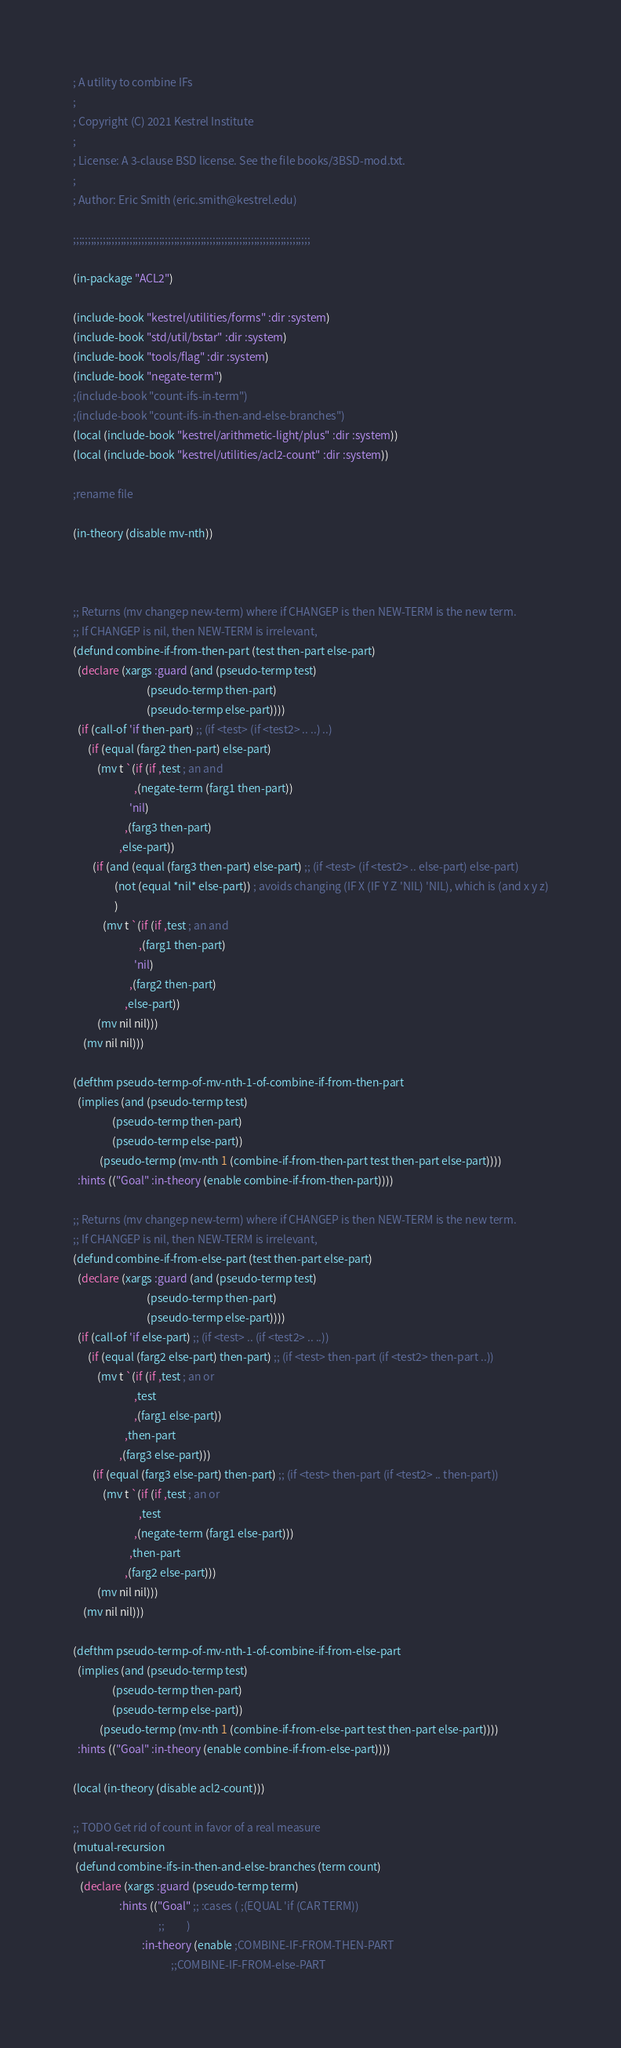<code> <loc_0><loc_0><loc_500><loc_500><_Lisp_>; A utility to combine IFs
;
; Copyright (C) 2021 Kestrel Institute
;
; License: A 3-clause BSD license. See the file books/3BSD-mod.txt.
;
; Author: Eric Smith (eric.smith@kestrel.edu)

;;;;;;;;;;;;;;;;;;;;;;;;;;;;;;;;;;;;;;;;;;;;;;;;;;;;;;;;;;;;;;;;;;;;;;;;;;;;;;;;

(in-package "ACL2")

(include-book "kestrel/utilities/forms" :dir :system)
(include-book "std/util/bstar" :dir :system)
(include-book "tools/flag" :dir :system)
(include-book "negate-term")
;(include-book "count-ifs-in-term")
;(include-book "count-ifs-in-then-and-else-branches")
(local (include-book "kestrel/arithmetic-light/plus" :dir :system))
(local (include-book "kestrel/utilities/acl2-count" :dir :system))

;rename file

(in-theory (disable mv-nth))



;; Returns (mv changep new-term) where if CHANGEP is then NEW-TERM is the new term.
;; If CHANGEP is nil, then NEW-TERM is irrelevant,
(defund combine-if-from-then-part (test then-part else-part)
  (declare (xargs :guard (and (pseudo-termp test)
                              (pseudo-termp then-part)
                              (pseudo-termp else-part))))
  (if (call-of 'if then-part) ;; (if <test> (if <test2> .. ..) ..)
      (if (equal (farg2 then-part) else-part)
          (mv t `(if (if ,test ; an and
                         ,(negate-term (farg1 then-part))
                       'nil)
                     ,(farg3 then-part)
                   ,else-part))
        (if (and (equal (farg3 then-part) else-part) ;; (if <test> (if <test2> .. else-part) else-part)
                 (not (equal *nil* else-part)) ; avoids changing (IF X (IF Y Z 'NIL) 'NIL), which is (and x y z)
                 )
            (mv t `(if (if ,test ; an and
                           ,(farg1 then-part)
                         'nil)
                       ,(farg2 then-part)
                     ,else-part))
          (mv nil nil)))
    (mv nil nil)))

(defthm pseudo-termp-of-mv-nth-1-of-combine-if-from-then-part
  (implies (and (pseudo-termp test)
                (pseudo-termp then-part)
                (pseudo-termp else-part))
           (pseudo-termp (mv-nth 1 (combine-if-from-then-part test then-part else-part))))
  :hints (("Goal" :in-theory (enable combine-if-from-then-part))))

;; Returns (mv changep new-term) where if CHANGEP is then NEW-TERM is the new term.
;; If CHANGEP is nil, then NEW-TERM is irrelevant,
(defund combine-if-from-else-part (test then-part else-part)
  (declare (xargs :guard (and (pseudo-termp test)
                              (pseudo-termp then-part)
                              (pseudo-termp else-part))))
  (if (call-of 'if else-part) ;; (if <test> .. (if <test2> .. ..))
      (if (equal (farg2 else-part) then-part) ;; (if <test> then-part (if <test2> then-part ..))
          (mv t `(if (if ,test ; an or
                         ,test
                         ,(farg1 else-part))
                     ,then-part
                   ,(farg3 else-part)))
        (if (equal (farg3 else-part) then-part) ;; (if <test> then-part (if <test2> .. then-part))
            (mv t `(if (if ,test ; an or
                           ,test
                         ,(negate-term (farg1 else-part)))
                       ,then-part
                     ,(farg2 else-part)))
          (mv nil nil)))
    (mv nil nil)))

(defthm pseudo-termp-of-mv-nth-1-of-combine-if-from-else-part
  (implies (and (pseudo-termp test)
                (pseudo-termp then-part)
                (pseudo-termp else-part))
           (pseudo-termp (mv-nth 1 (combine-if-from-else-part test then-part else-part))))
  :hints (("Goal" :in-theory (enable combine-if-from-else-part))))

(local (in-theory (disable acl2-count)))

;; TODO Get rid of count in favor of a real measure
(mutual-recursion
 (defund combine-ifs-in-then-and-else-branches (term count)
   (declare (xargs :guard (pseudo-termp term)
                   :hints (("Goal" ;; :cases ( ;(EQUAL 'if (CAR TERM))
                                   ;;         )
                            :in-theory (enable ;COMBINE-IF-FROM-THEN-PART
                                        ;;COMBINE-IF-FROM-else-PART</code> 